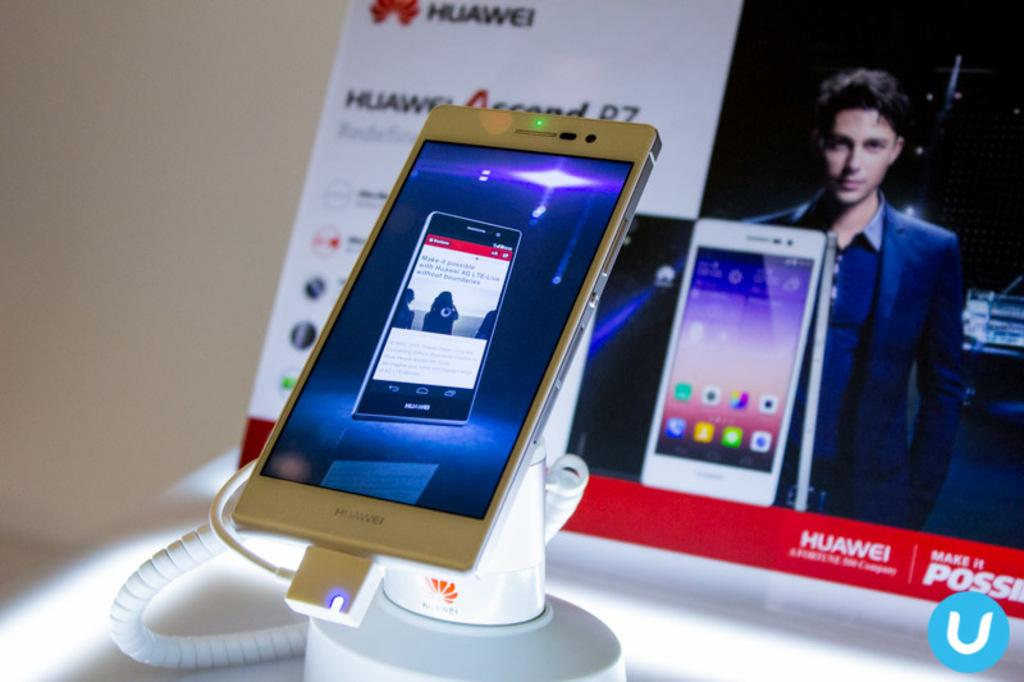<image>
Summarize the visual content of the image. A phone made by the company HUAWEI is on display. 